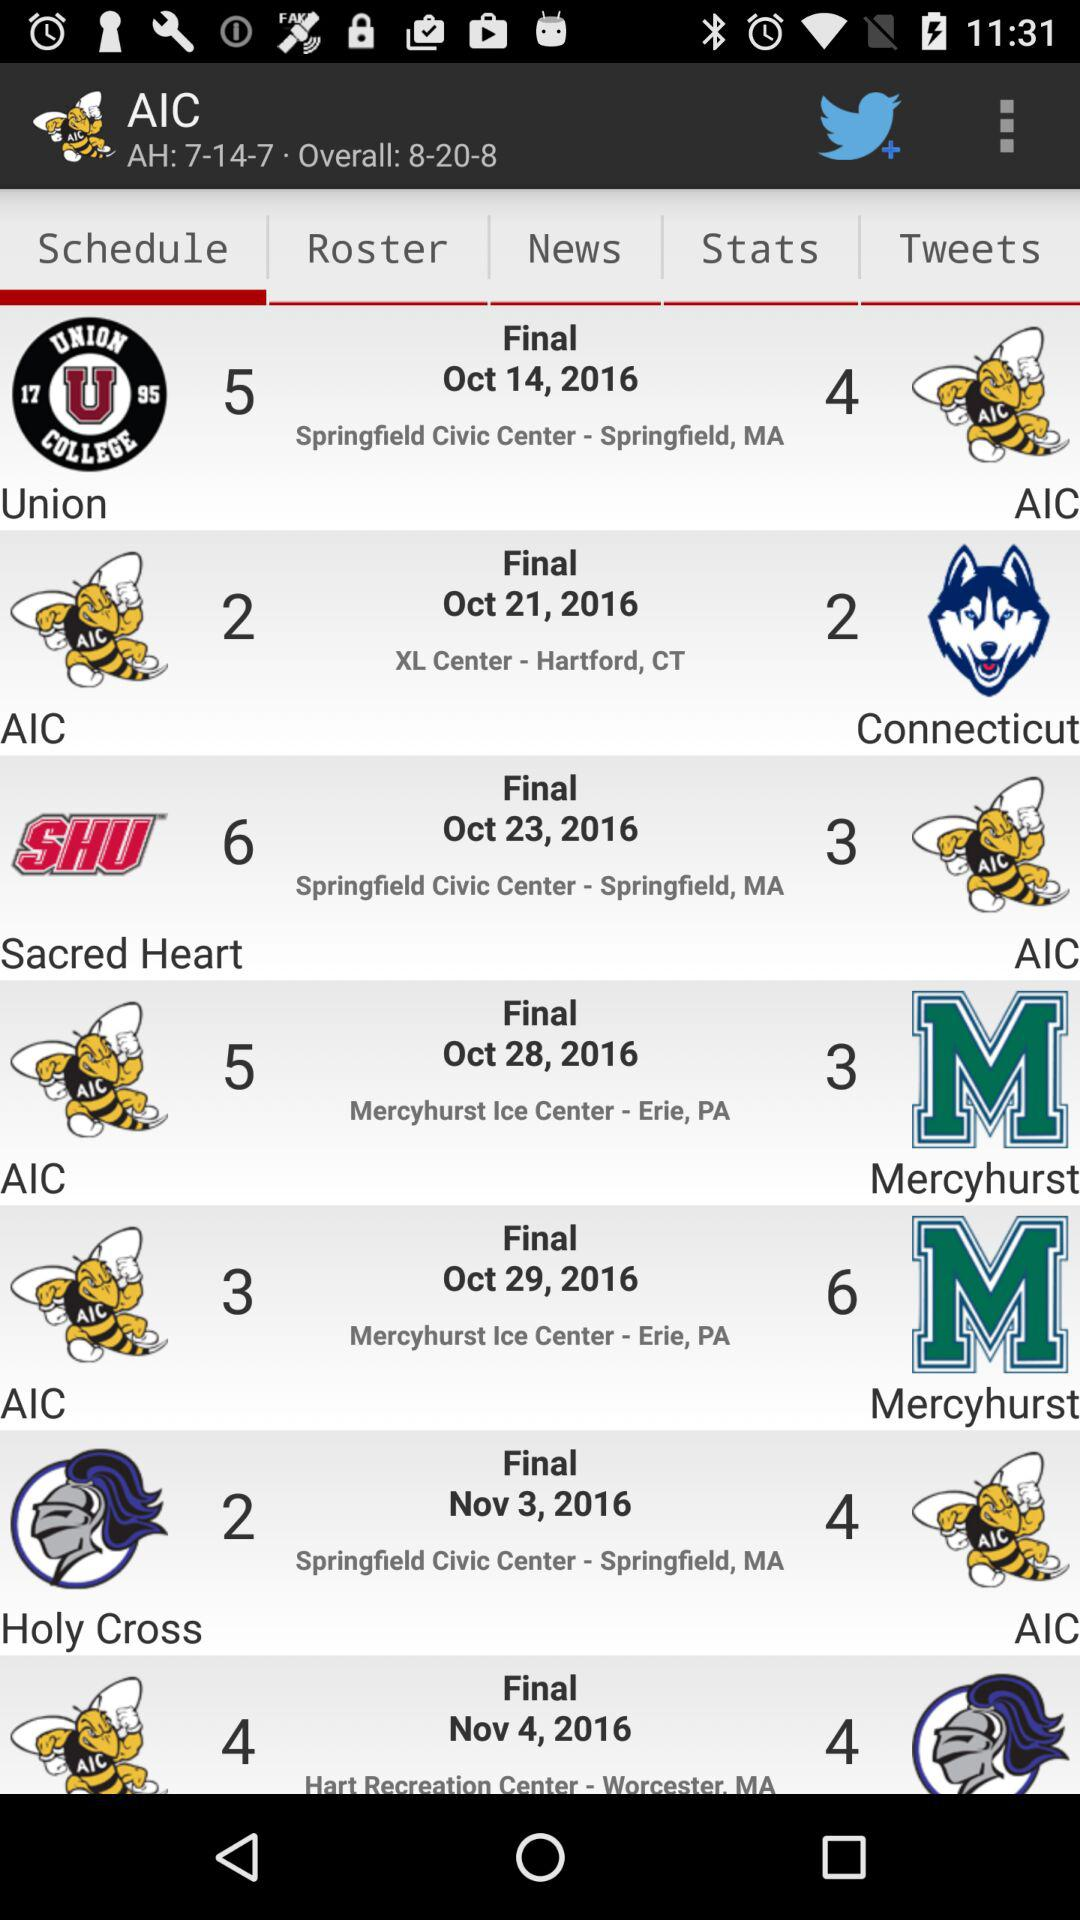What's the scheduled date of the final between "Holy Cross" and AIC? The scheduled date of the final between "Holy Cross" and AIC is November 3, 2016. 